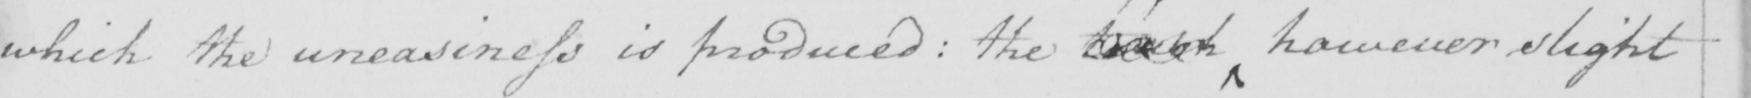What does this handwritten line say? which the uneasiness is produced :  the touch however slight 